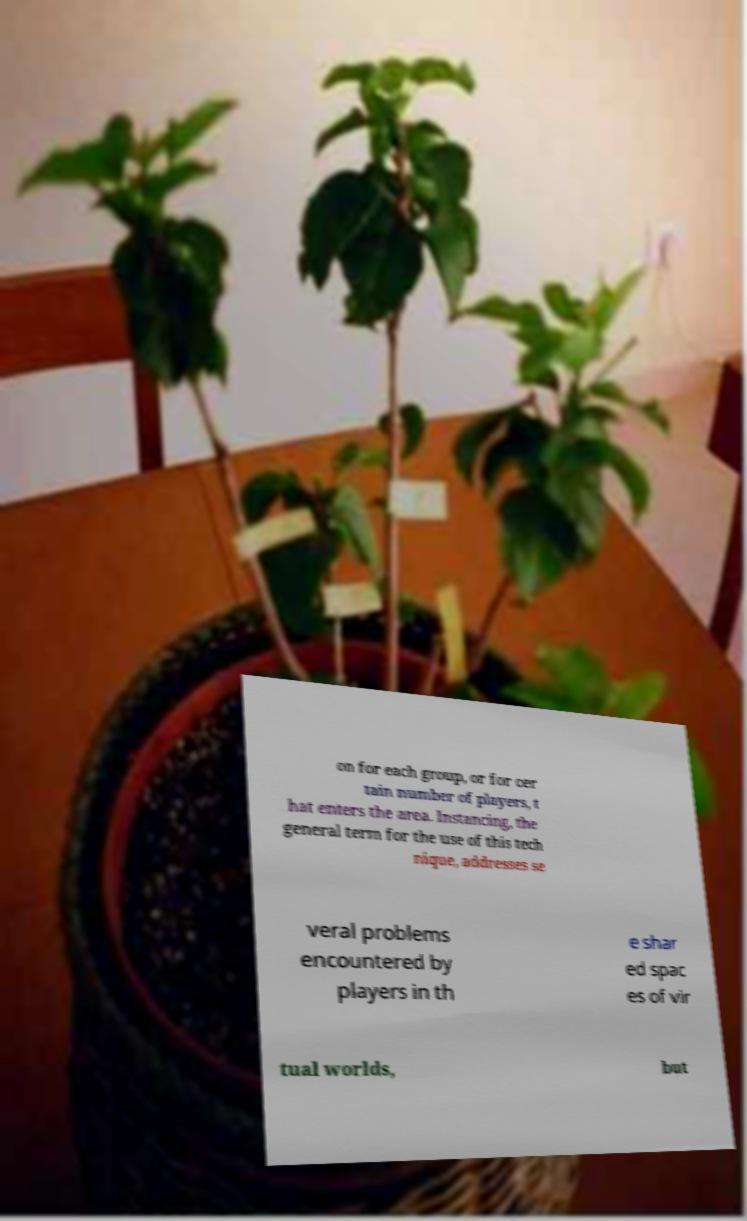Please read and relay the text visible in this image. What does it say? on for each group, or for cer tain number of players, t hat enters the area. Instancing, the general term for the use of this tech nique, addresses se veral problems encountered by players in th e shar ed spac es of vir tual worlds, but 